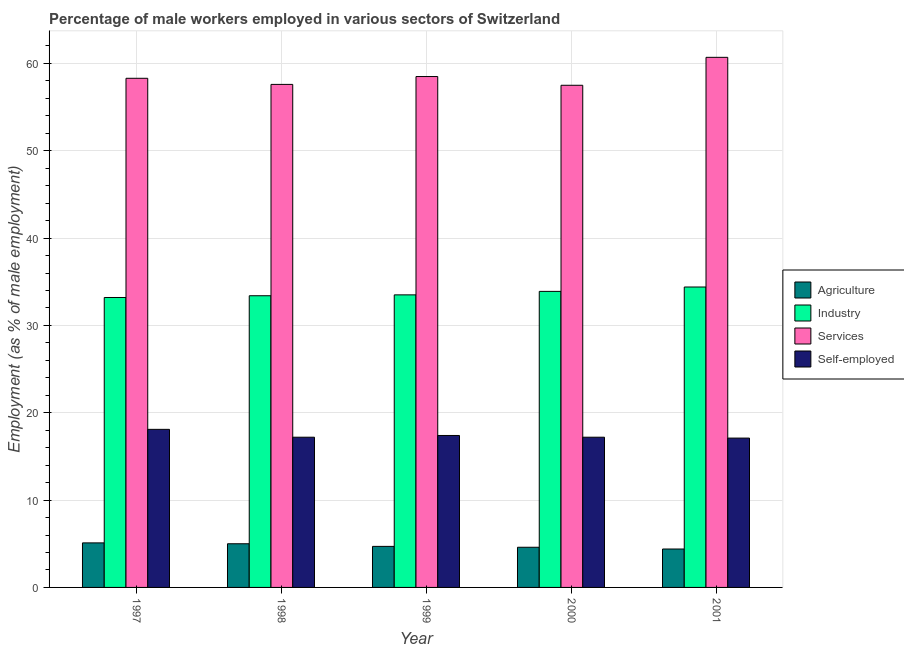How many different coloured bars are there?
Your response must be concise. 4. How many groups of bars are there?
Your answer should be compact. 5. Are the number of bars per tick equal to the number of legend labels?
Give a very brief answer. Yes. What is the percentage of male workers in industry in 1998?
Make the answer very short. 33.4. Across all years, what is the maximum percentage of self employed male workers?
Offer a terse response. 18.1. Across all years, what is the minimum percentage of male workers in agriculture?
Offer a very short reply. 4.4. In which year was the percentage of self employed male workers minimum?
Your answer should be very brief. 2001. What is the total percentage of male workers in industry in the graph?
Provide a succinct answer. 168.4. What is the difference between the percentage of self employed male workers in 1999 and that in 2001?
Your answer should be very brief. 0.3. What is the difference between the percentage of male workers in agriculture in 1998 and the percentage of male workers in services in 2000?
Your response must be concise. 0.4. What is the average percentage of male workers in services per year?
Your response must be concise. 58.52. What is the ratio of the percentage of self employed male workers in 1998 to that in 2001?
Offer a terse response. 1.01. Is the percentage of male workers in industry in 1998 less than that in 2001?
Your answer should be compact. Yes. Is the difference between the percentage of male workers in industry in 1997 and 1998 greater than the difference between the percentage of male workers in services in 1997 and 1998?
Offer a terse response. No. What is the difference between the highest and the second highest percentage of male workers in agriculture?
Your answer should be compact. 0.1. What is the difference between the highest and the lowest percentage of male workers in agriculture?
Your answer should be very brief. 0.7. In how many years, is the percentage of male workers in agriculture greater than the average percentage of male workers in agriculture taken over all years?
Your response must be concise. 2. Is the sum of the percentage of self employed male workers in 1999 and 2000 greater than the maximum percentage of male workers in services across all years?
Provide a short and direct response. Yes. What does the 1st bar from the left in 1997 represents?
Your answer should be very brief. Agriculture. What does the 3rd bar from the right in 1998 represents?
Your answer should be very brief. Industry. Is it the case that in every year, the sum of the percentage of male workers in agriculture and percentage of male workers in industry is greater than the percentage of male workers in services?
Ensure brevity in your answer.  No. How many years are there in the graph?
Give a very brief answer. 5. What is the difference between two consecutive major ticks on the Y-axis?
Your response must be concise. 10. Does the graph contain grids?
Provide a short and direct response. Yes. How many legend labels are there?
Give a very brief answer. 4. What is the title of the graph?
Keep it short and to the point. Percentage of male workers employed in various sectors of Switzerland. What is the label or title of the Y-axis?
Ensure brevity in your answer.  Employment (as % of male employment). What is the Employment (as % of male employment) in Agriculture in 1997?
Your response must be concise. 5.1. What is the Employment (as % of male employment) in Industry in 1997?
Your response must be concise. 33.2. What is the Employment (as % of male employment) of Services in 1997?
Keep it short and to the point. 58.3. What is the Employment (as % of male employment) of Self-employed in 1997?
Provide a short and direct response. 18.1. What is the Employment (as % of male employment) of Agriculture in 1998?
Keep it short and to the point. 5. What is the Employment (as % of male employment) in Industry in 1998?
Give a very brief answer. 33.4. What is the Employment (as % of male employment) in Services in 1998?
Make the answer very short. 57.6. What is the Employment (as % of male employment) in Self-employed in 1998?
Offer a terse response. 17.2. What is the Employment (as % of male employment) of Agriculture in 1999?
Offer a very short reply. 4.7. What is the Employment (as % of male employment) of Industry in 1999?
Offer a very short reply. 33.5. What is the Employment (as % of male employment) in Services in 1999?
Provide a short and direct response. 58.5. What is the Employment (as % of male employment) of Self-employed in 1999?
Your response must be concise. 17.4. What is the Employment (as % of male employment) of Agriculture in 2000?
Offer a terse response. 4.6. What is the Employment (as % of male employment) in Industry in 2000?
Give a very brief answer. 33.9. What is the Employment (as % of male employment) of Services in 2000?
Your answer should be compact. 57.5. What is the Employment (as % of male employment) in Self-employed in 2000?
Provide a succinct answer. 17.2. What is the Employment (as % of male employment) of Agriculture in 2001?
Your answer should be compact. 4.4. What is the Employment (as % of male employment) in Industry in 2001?
Keep it short and to the point. 34.4. What is the Employment (as % of male employment) of Services in 2001?
Offer a very short reply. 60.7. What is the Employment (as % of male employment) of Self-employed in 2001?
Your response must be concise. 17.1. Across all years, what is the maximum Employment (as % of male employment) in Agriculture?
Provide a short and direct response. 5.1. Across all years, what is the maximum Employment (as % of male employment) of Industry?
Give a very brief answer. 34.4. Across all years, what is the maximum Employment (as % of male employment) in Services?
Your response must be concise. 60.7. Across all years, what is the maximum Employment (as % of male employment) in Self-employed?
Provide a succinct answer. 18.1. Across all years, what is the minimum Employment (as % of male employment) of Agriculture?
Your answer should be very brief. 4.4. Across all years, what is the minimum Employment (as % of male employment) in Industry?
Offer a terse response. 33.2. Across all years, what is the minimum Employment (as % of male employment) of Services?
Offer a very short reply. 57.5. Across all years, what is the minimum Employment (as % of male employment) of Self-employed?
Ensure brevity in your answer.  17.1. What is the total Employment (as % of male employment) of Agriculture in the graph?
Your response must be concise. 23.8. What is the total Employment (as % of male employment) in Industry in the graph?
Your answer should be very brief. 168.4. What is the total Employment (as % of male employment) in Services in the graph?
Offer a very short reply. 292.6. What is the total Employment (as % of male employment) in Self-employed in the graph?
Ensure brevity in your answer.  87. What is the difference between the Employment (as % of male employment) of Services in 1997 and that in 1998?
Your response must be concise. 0.7. What is the difference between the Employment (as % of male employment) of Self-employed in 1997 and that in 1998?
Make the answer very short. 0.9. What is the difference between the Employment (as % of male employment) of Agriculture in 1997 and that in 1999?
Make the answer very short. 0.4. What is the difference between the Employment (as % of male employment) in Industry in 1997 and that in 1999?
Ensure brevity in your answer.  -0.3. What is the difference between the Employment (as % of male employment) of Self-employed in 1997 and that in 1999?
Provide a short and direct response. 0.7. What is the difference between the Employment (as % of male employment) in Services in 1997 and that in 2000?
Your answer should be very brief. 0.8. What is the difference between the Employment (as % of male employment) of Self-employed in 1997 and that in 2000?
Make the answer very short. 0.9. What is the difference between the Employment (as % of male employment) in Agriculture in 1997 and that in 2001?
Provide a succinct answer. 0.7. What is the difference between the Employment (as % of male employment) of Industry in 1997 and that in 2001?
Your response must be concise. -1.2. What is the difference between the Employment (as % of male employment) of Industry in 1998 and that in 1999?
Provide a short and direct response. -0.1. What is the difference between the Employment (as % of male employment) of Services in 1998 and that in 2001?
Offer a terse response. -3.1. What is the difference between the Employment (as % of male employment) of Agriculture in 1999 and that in 2000?
Provide a succinct answer. 0.1. What is the difference between the Employment (as % of male employment) in Industry in 1999 and that in 2000?
Offer a very short reply. -0.4. What is the difference between the Employment (as % of male employment) in Services in 1999 and that in 2000?
Your answer should be compact. 1. What is the difference between the Employment (as % of male employment) of Self-employed in 1999 and that in 2000?
Offer a very short reply. 0.2. What is the difference between the Employment (as % of male employment) in Agriculture in 1999 and that in 2001?
Give a very brief answer. 0.3. What is the difference between the Employment (as % of male employment) of Agriculture in 2000 and that in 2001?
Your answer should be very brief. 0.2. What is the difference between the Employment (as % of male employment) in Industry in 2000 and that in 2001?
Your response must be concise. -0.5. What is the difference between the Employment (as % of male employment) in Services in 2000 and that in 2001?
Ensure brevity in your answer.  -3.2. What is the difference between the Employment (as % of male employment) of Self-employed in 2000 and that in 2001?
Give a very brief answer. 0.1. What is the difference between the Employment (as % of male employment) in Agriculture in 1997 and the Employment (as % of male employment) in Industry in 1998?
Make the answer very short. -28.3. What is the difference between the Employment (as % of male employment) of Agriculture in 1997 and the Employment (as % of male employment) of Services in 1998?
Your answer should be very brief. -52.5. What is the difference between the Employment (as % of male employment) of Agriculture in 1997 and the Employment (as % of male employment) of Self-employed in 1998?
Ensure brevity in your answer.  -12.1. What is the difference between the Employment (as % of male employment) in Industry in 1997 and the Employment (as % of male employment) in Services in 1998?
Your response must be concise. -24.4. What is the difference between the Employment (as % of male employment) of Services in 1997 and the Employment (as % of male employment) of Self-employed in 1998?
Offer a very short reply. 41.1. What is the difference between the Employment (as % of male employment) of Agriculture in 1997 and the Employment (as % of male employment) of Industry in 1999?
Your answer should be compact. -28.4. What is the difference between the Employment (as % of male employment) of Agriculture in 1997 and the Employment (as % of male employment) of Services in 1999?
Your answer should be compact. -53.4. What is the difference between the Employment (as % of male employment) of Agriculture in 1997 and the Employment (as % of male employment) of Self-employed in 1999?
Provide a short and direct response. -12.3. What is the difference between the Employment (as % of male employment) in Industry in 1997 and the Employment (as % of male employment) in Services in 1999?
Your answer should be very brief. -25.3. What is the difference between the Employment (as % of male employment) in Services in 1997 and the Employment (as % of male employment) in Self-employed in 1999?
Provide a short and direct response. 40.9. What is the difference between the Employment (as % of male employment) in Agriculture in 1997 and the Employment (as % of male employment) in Industry in 2000?
Keep it short and to the point. -28.8. What is the difference between the Employment (as % of male employment) of Agriculture in 1997 and the Employment (as % of male employment) of Services in 2000?
Provide a short and direct response. -52.4. What is the difference between the Employment (as % of male employment) in Agriculture in 1997 and the Employment (as % of male employment) in Self-employed in 2000?
Your answer should be compact. -12.1. What is the difference between the Employment (as % of male employment) in Industry in 1997 and the Employment (as % of male employment) in Services in 2000?
Provide a short and direct response. -24.3. What is the difference between the Employment (as % of male employment) in Services in 1997 and the Employment (as % of male employment) in Self-employed in 2000?
Offer a very short reply. 41.1. What is the difference between the Employment (as % of male employment) of Agriculture in 1997 and the Employment (as % of male employment) of Industry in 2001?
Keep it short and to the point. -29.3. What is the difference between the Employment (as % of male employment) of Agriculture in 1997 and the Employment (as % of male employment) of Services in 2001?
Make the answer very short. -55.6. What is the difference between the Employment (as % of male employment) of Agriculture in 1997 and the Employment (as % of male employment) of Self-employed in 2001?
Provide a succinct answer. -12. What is the difference between the Employment (as % of male employment) of Industry in 1997 and the Employment (as % of male employment) of Services in 2001?
Provide a succinct answer. -27.5. What is the difference between the Employment (as % of male employment) in Services in 1997 and the Employment (as % of male employment) in Self-employed in 2001?
Give a very brief answer. 41.2. What is the difference between the Employment (as % of male employment) in Agriculture in 1998 and the Employment (as % of male employment) in Industry in 1999?
Ensure brevity in your answer.  -28.5. What is the difference between the Employment (as % of male employment) of Agriculture in 1998 and the Employment (as % of male employment) of Services in 1999?
Your answer should be very brief. -53.5. What is the difference between the Employment (as % of male employment) in Agriculture in 1998 and the Employment (as % of male employment) in Self-employed in 1999?
Your answer should be compact. -12.4. What is the difference between the Employment (as % of male employment) of Industry in 1998 and the Employment (as % of male employment) of Services in 1999?
Keep it short and to the point. -25.1. What is the difference between the Employment (as % of male employment) of Industry in 1998 and the Employment (as % of male employment) of Self-employed in 1999?
Offer a very short reply. 16. What is the difference between the Employment (as % of male employment) of Services in 1998 and the Employment (as % of male employment) of Self-employed in 1999?
Give a very brief answer. 40.2. What is the difference between the Employment (as % of male employment) of Agriculture in 1998 and the Employment (as % of male employment) of Industry in 2000?
Give a very brief answer. -28.9. What is the difference between the Employment (as % of male employment) in Agriculture in 1998 and the Employment (as % of male employment) in Services in 2000?
Keep it short and to the point. -52.5. What is the difference between the Employment (as % of male employment) of Industry in 1998 and the Employment (as % of male employment) of Services in 2000?
Offer a terse response. -24.1. What is the difference between the Employment (as % of male employment) of Services in 1998 and the Employment (as % of male employment) of Self-employed in 2000?
Your answer should be very brief. 40.4. What is the difference between the Employment (as % of male employment) of Agriculture in 1998 and the Employment (as % of male employment) of Industry in 2001?
Your response must be concise. -29.4. What is the difference between the Employment (as % of male employment) in Agriculture in 1998 and the Employment (as % of male employment) in Services in 2001?
Offer a very short reply. -55.7. What is the difference between the Employment (as % of male employment) in Industry in 1998 and the Employment (as % of male employment) in Services in 2001?
Ensure brevity in your answer.  -27.3. What is the difference between the Employment (as % of male employment) in Services in 1998 and the Employment (as % of male employment) in Self-employed in 2001?
Give a very brief answer. 40.5. What is the difference between the Employment (as % of male employment) in Agriculture in 1999 and the Employment (as % of male employment) in Industry in 2000?
Provide a short and direct response. -29.2. What is the difference between the Employment (as % of male employment) in Agriculture in 1999 and the Employment (as % of male employment) in Services in 2000?
Offer a terse response. -52.8. What is the difference between the Employment (as % of male employment) of Agriculture in 1999 and the Employment (as % of male employment) of Self-employed in 2000?
Provide a succinct answer. -12.5. What is the difference between the Employment (as % of male employment) of Industry in 1999 and the Employment (as % of male employment) of Services in 2000?
Your answer should be very brief. -24. What is the difference between the Employment (as % of male employment) of Industry in 1999 and the Employment (as % of male employment) of Self-employed in 2000?
Provide a short and direct response. 16.3. What is the difference between the Employment (as % of male employment) in Services in 1999 and the Employment (as % of male employment) in Self-employed in 2000?
Your answer should be compact. 41.3. What is the difference between the Employment (as % of male employment) of Agriculture in 1999 and the Employment (as % of male employment) of Industry in 2001?
Your response must be concise. -29.7. What is the difference between the Employment (as % of male employment) in Agriculture in 1999 and the Employment (as % of male employment) in Services in 2001?
Offer a terse response. -56. What is the difference between the Employment (as % of male employment) in Industry in 1999 and the Employment (as % of male employment) in Services in 2001?
Offer a terse response. -27.2. What is the difference between the Employment (as % of male employment) of Industry in 1999 and the Employment (as % of male employment) of Self-employed in 2001?
Provide a succinct answer. 16.4. What is the difference between the Employment (as % of male employment) in Services in 1999 and the Employment (as % of male employment) in Self-employed in 2001?
Keep it short and to the point. 41.4. What is the difference between the Employment (as % of male employment) in Agriculture in 2000 and the Employment (as % of male employment) in Industry in 2001?
Your response must be concise. -29.8. What is the difference between the Employment (as % of male employment) in Agriculture in 2000 and the Employment (as % of male employment) in Services in 2001?
Provide a short and direct response. -56.1. What is the difference between the Employment (as % of male employment) of Agriculture in 2000 and the Employment (as % of male employment) of Self-employed in 2001?
Keep it short and to the point. -12.5. What is the difference between the Employment (as % of male employment) in Industry in 2000 and the Employment (as % of male employment) in Services in 2001?
Make the answer very short. -26.8. What is the difference between the Employment (as % of male employment) in Services in 2000 and the Employment (as % of male employment) in Self-employed in 2001?
Your answer should be compact. 40.4. What is the average Employment (as % of male employment) of Agriculture per year?
Offer a terse response. 4.76. What is the average Employment (as % of male employment) of Industry per year?
Ensure brevity in your answer.  33.68. What is the average Employment (as % of male employment) of Services per year?
Provide a short and direct response. 58.52. What is the average Employment (as % of male employment) of Self-employed per year?
Provide a succinct answer. 17.4. In the year 1997, what is the difference between the Employment (as % of male employment) in Agriculture and Employment (as % of male employment) in Industry?
Your answer should be very brief. -28.1. In the year 1997, what is the difference between the Employment (as % of male employment) in Agriculture and Employment (as % of male employment) in Services?
Keep it short and to the point. -53.2. In the year 1997, what is the difference between the Employment (as % of male employment) in Industry and Employment (as % of male employment) in Services?
Offer a very short reply. -25.1. In the year 1997, what is the difference between the Employment (as % of male employment) in Industry and Employment (as % of male employment) in Self-employed?
Keep it short and to the point. 15.1. In the year 1997, what is the difference between the Employment (as % of male employment) in Services and Employment (as % of male employment) in Self-employed?
Provide a succinct answer. 40.2. In the year 1998, what is the difference between the Employment (as % of male employment) of Agriculture and Employment (as % of male employment) of Industry?
Your answer should be compact. -28.4. In the year 1998, what is the difference between the Employment (as % of male employment) of Agriculture and Employment (as % of male employment) of Services?
Keep it short and to the point. -52.6. In the year 1998, what is the difference between the Employment (as % of male employment) in Agriculture and Employment (as % of male employment) in Self-employed?
Offer a terse response. -12.2. In the year 1998, what is the difference between the Employment (as % of male employment) in Industry and Employment (as % of male employment) in Services?
Give a very brief answer. -24.2. In the year 1998, what is the difference between the Employment (as % of male employment) in Services and Employment (as % of male employment) in Self-employed?
Provide a succinct answer. 40.4. In the year 1999, what is the difference between the Employment (as % of male employment) in Agriculture and Employment (as % of male employment) in Industry?
Provide a succinct answer. -28.8. In the year 1999, what is the difference between the Employment (as % of male employment) of Agriculture and Employment (as % of male employment) of Services?
Give a very brief answer. -53.8. In the year 1999, what is the difference between the Employment (as % of male employment) of Agriculture and Employment (as % of male employment) of Self-employed?
Your answer should be compact. -12.7. In the year 1999, what is the difference between the Employment (as % of male employment) in Industry and Employment (as % of male employment) in Services?
Offer a terse response. -25. In the year 1999, what is the difference between the Employment (as % of male employment) in Services and Employment (as % of male employment) in Self-employed?
Offer a terse response. 41.1. In the year 2000, what is the difference between the Employment (as % of male employment) of Agriculture and Employment (as % of male employment) of Industry?
Make the answer very short. -29.3. In the year 2000, what is the difference between the Employment (as % of male employment) of Agriculture and Employment (as % of male employment) of Services?
Keep it short and to the point. -52.9. In the year 2000, what is the difference between the Employment (as % of male employment) in Industry and Employment (as % of male employment) in Services?
Make the answer very short. -23.6. In the year 2000, what is the difference between the Employment (as % of male employment) in Industry and Employment (as % of male employment) in Self-employed?
Ensure brevity in your answer.  16.7. In the year 2000, what is the difference between the Employment (as % of male employment) of Services and Employment (as % of male employment) of Self-employed?
Make the answer very short. 40.3. In the year 2001, what is the difference between the Employment (as % of male employment) in Agriculture and Employment (as % of male employment) in Industry?
Keep it short and to the point. -30. In the year 2001, what is the difference between the Employment (as % of male employment) of Agriculture and Employment (as % of male employment) of Services?
Provide a succinct answer. -56.3. In the year 2001, what is the difference between the Employment (as % of male employment) in Industry and Employment (as % of male employment) in Services?
Make the answer very short. -26.3. In the year 2001, what is the difference between the Employment (as % of male employment) of Industry and Employment (as % of male employment) of Self-employed?
Offer a very short reply. 17.3. In the year 2001, what is the difference between the Employment (as % of male employment) of Services and Employment (as % of male employment) of Self-employed?
Ensure brevity in your answer.  43.6. What is the ratio of the Employment (as % of male employment) in Services in 1997 to that in 1998?
Offer a very short reply. 1.01. What is the ratio of the Employment (as % of male employment) in Self-employed in 1997 to that in 1998?
Provide a short and direct response. 1.05. What is the ratio of the Employment (as % of male employment) of Agriculture in 1997 to that in 1999?
Keep it short and to the point. 1.09. What is the ratio of the Employment (as % of male employment) of Self-employed in 1997 to that in 1999?
Your response must be concise. 1.04. What is the ratio of the Employment (as % of male employment) of Agriculture in 1997 to that in 2000?
Ensure brevity in your answer.  1.11. What is the ratio of the Employment (as % of male employment) in Industry in 1997 to that in 2000?
Ensure brevity in your answer.  0.98. What is the ratio of the Employment (as % of male employment) of Services in 1997 to that in 2000?
Your answer should be compact. 1.01. What is the ratio of the Employment (as % of male employment) of Self-employed in 1997 to that in 2000?
Make the answer very short. 1.05. What is the ratio of the Employment (as % of male employment) in Agriculture in 1997 to that in 2001?
Provide a short and direct response. 1.16. What is the ratio of the Employment (as % of male employment) of Industry in 1997 to that in 2001?
Ensure brevity in your answer.  0.97. What is the ratio of the Employment (as % of male employment) in Services in 1997 to that in 2001?
Provide a succinct answer. 0.96. What is the ratio of the Employment (as % of male employment) in Self-employed in 1997 to that in 2001?
Offer a terse response. 1.06. What is the ratio of the Employment (as % of male employment) in Agriculture in 1998 to that in 1999?
Ensure brevity in your answer.  1.06. What is the ratio of the Employment (as % of male employment) in Services in 1998 to that in 1999?
Your answer should be compact. 0.98. What is the ratio of the Employment (as % of male employment) in Agriculture in 1998 to that in 2000?
Offer a terse response. 1.09. What is the ratio of the Employment (as % of male employment) in Agriculture in 1998 to that in 2001?
Your response must be concise. 1.14. What is the ratio of the Employment (as % of male employment) in Industry in 1998 to that in 2001?
Provide a succinct answer. 0.97. What is the ratio of the Employment (as % of male employment) in Services in 1998 to that in 2001?
Your answer should be very brief. 0.95. What is the ratio of the Employment (as % of male employment) in Agriculture in 1999 to that in 2000?
Keep it short and to the point. 1.02. What is the ratio of the Employment (as % of male employment) in Services in 1999 to that in 2000?
Give a very brief answer. 1.02. What is the ratio of the Employment (as % of male employment) in Self-employed in 1999 to that in 2000?
Give a very brief answer. 1.01. What is the ratio of the Employment (as % of male employment) of Agriculture in 1999 to that in 2001?
Make the answer very short. 1.07. What is the ratio of the Employment (as % of male employment) of Industry in 1999 to that in 2001?
Keep it short and to the point. 0.97. What is the ratio of the Employment (as % of male employment) in Services in 1999 to that in 2001?
Give a very brief answer. 0.96. What is the ratio of the Employment (as % of male employment) in Self-employed in 1999 to that in 2001?
Keep it short and to the point. 1.02. What is the ratio of the Employment (as % of male employment) of Agriculture in 2000 to that in 2001?
Provide a succinct answer. 1.05. What is the ratio of the Employment (as % of male employment) of Industry in 2000 to that in 2001?
Give a very brief answer. 0.99. What is the ratio of the Employment (as % of male employment) in Services in 2000 to that in 2001?
Give a very brief answer. 0.95. What is the ratio of the Employment (as % of male employment) of Self-employed in 2000 to that in 2001?
Provide a succinct answer. 1.01. What is the difference between the highest and the second highest Employment (as % of male employment) in Industry?
Provide a short and direct response. 0.5. What is the difference between the highest and the lowest Employment (as % of male employment) of Agriculture?
Your response must be concise. 0.7. What is the difference between the highest and the lowest Employment (as % of male employment) in Services?
Offer a very short reply. 3.2. 